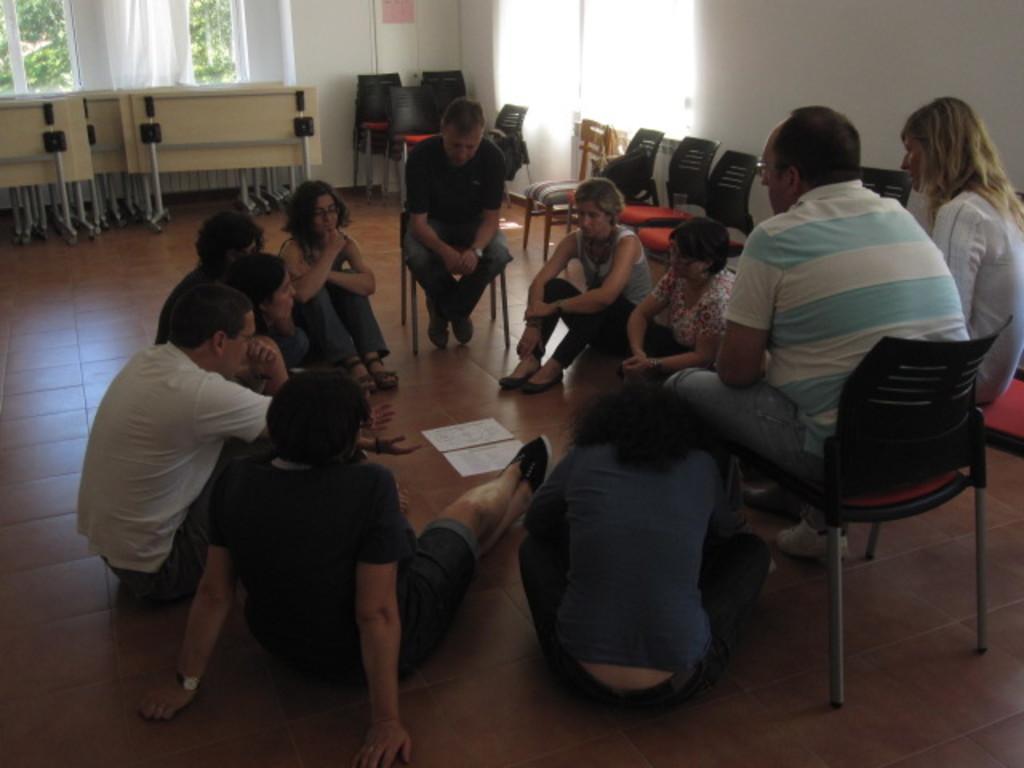How would you summarize this image in a sentence or two? In this picture we can see some persons are sitting on the floor and these three are sitting on the chairs. This is the floor. And here we can see some trees from the window. And there is a wall. 